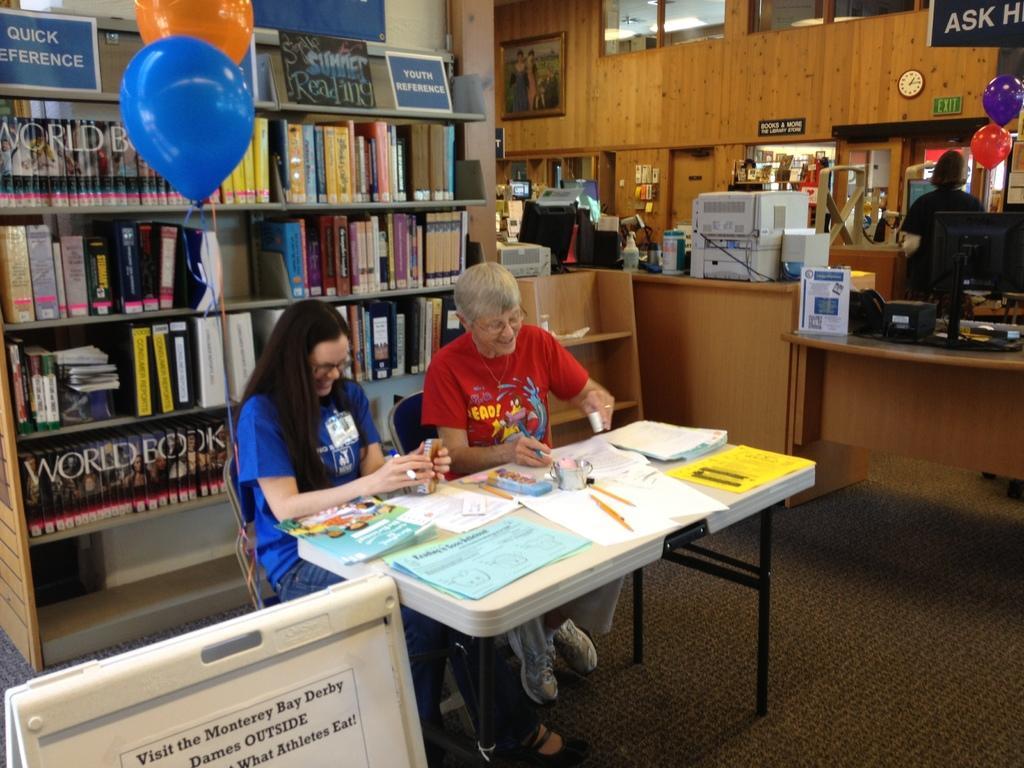Please provide a concise description of this image. In this image we can see two women sitting on chairs placed on the floor. One woman is wearing a red t shirt and other woman is wearing spectacles and blue t shirt. In the foreground we can see a table on which group of papers and pens are placed. In the background, we can see group of books placed in a rack, group of balloons, screen and a person standing, some machines and a clock on the wall. 